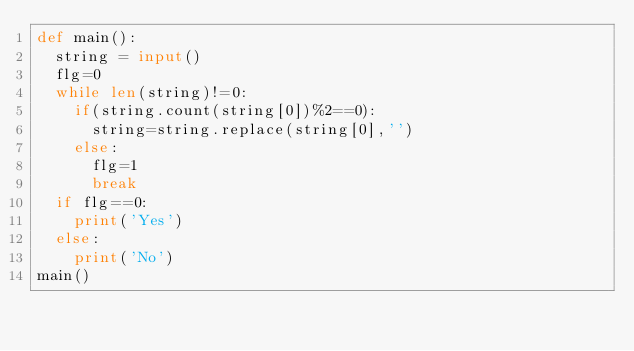<code> <loc_0><loc_0><loc_500><loc_500><_Python_>def main():
  string = input()
  flg=0
  while len(string)!=0:
    if(string.count(string[0])%2==0):
      string=string.replace(string[0],'')
    else:
      flg=1
      break
  if flg==0:
    print('Yes')
  else:
    print('No')  
main()</code> 